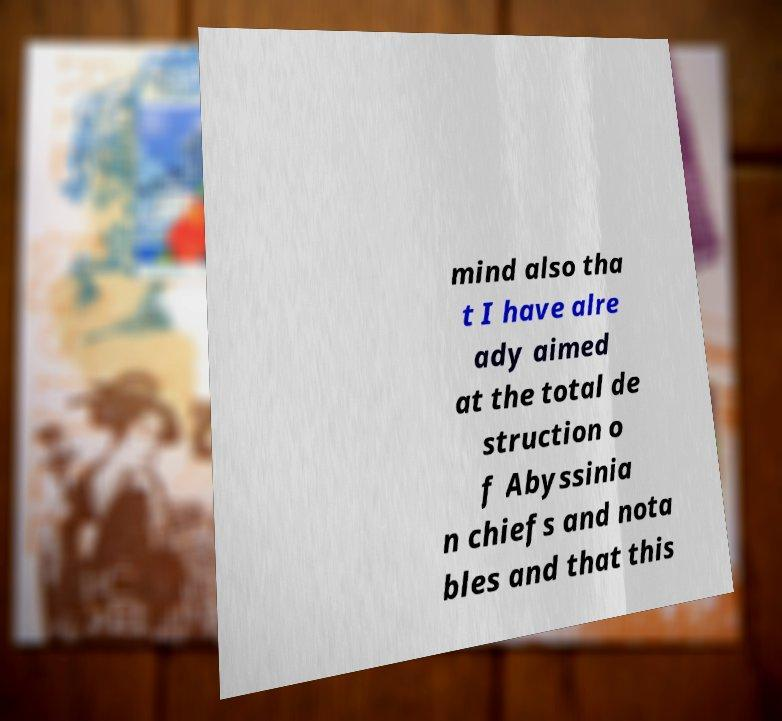What messages or text are displayed in this image? I need them in a readable, typed format. mind also tha t I have alre ady aimed at the total de struction o f Abyssinia n chiefs and nota bles and that this 